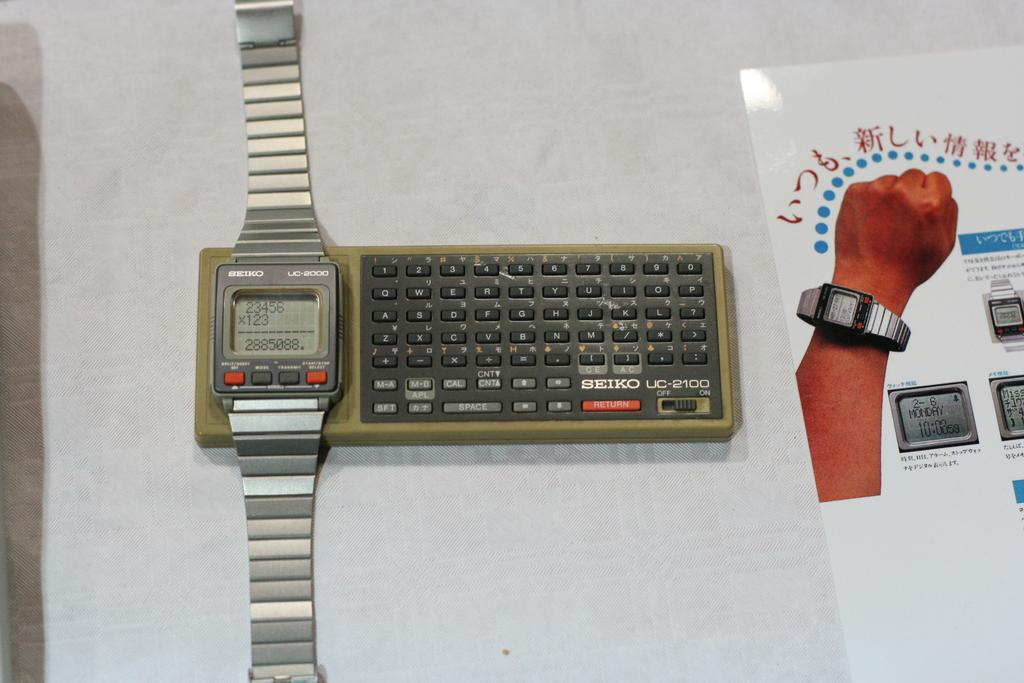Provide a one-sentence caption for the provided image. A Seiko wristwatch and other device lying together on a table. 